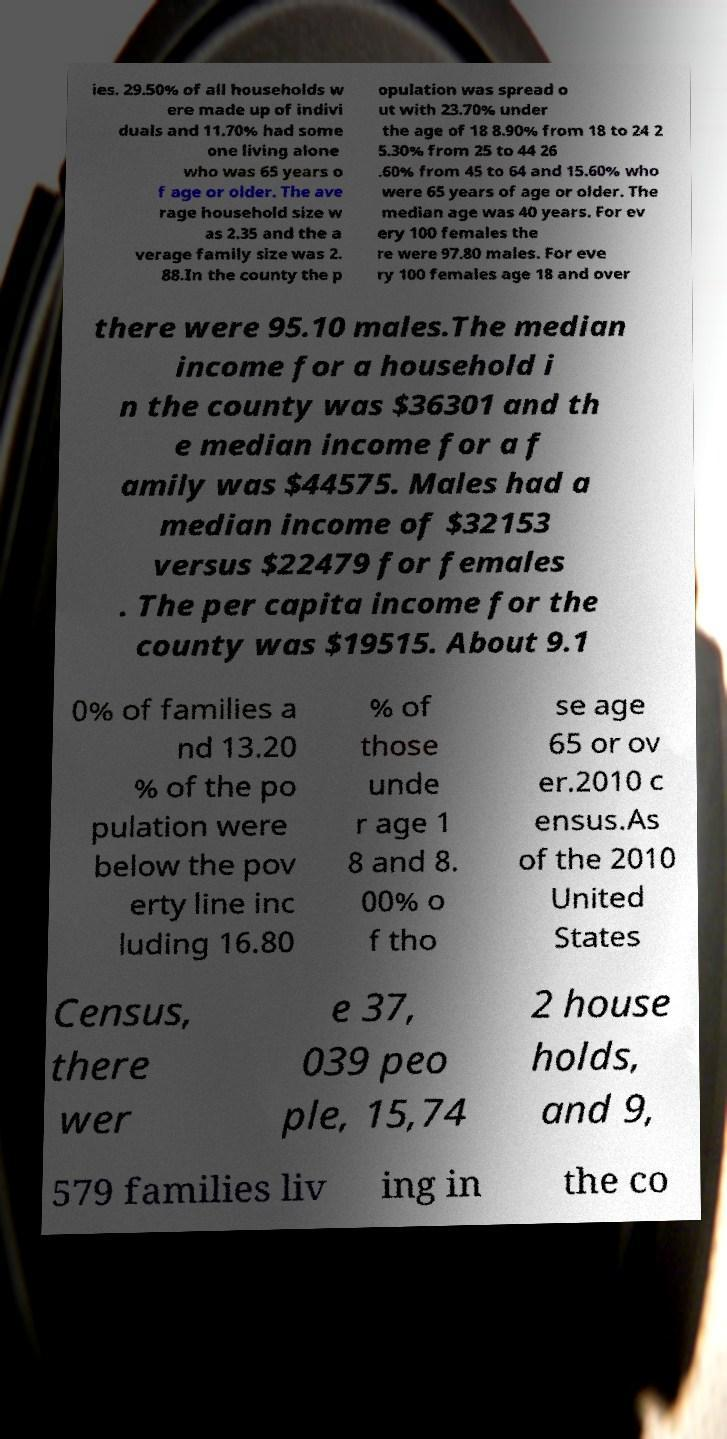Please identify and transcribe the text found in this image. ies. 29.50% of all households w ere made up of indivi duals and 11.70% had some one living alone who was 65 years o f age or older. The ave rage household size w as 2.35 and the a verage family size was 2. 88.In the county the p opulation was spread o ut with 23.70% under the age of 18 8.90% from 18 to 24 2 5.30% from 25 to 44 26 .60% from 45 to 64 and 15.60% who were 65 years of age or older. The median age was 40 years. For ev ery 100 females the re were 97.80 males. For eve ry 100 females age 18 and over there were 95.10 males.The median income for a household i n the county was $36301 and th e median income for a f amily was $44575. Males had a median income of $32153 versus $22479 for females . The per capita income for the county was $19515. About 9.1 0% of families a nd 13.20 % of the po pulation were below the pov erty line inc luding 16.80 % of those unde r age 1 8 and 8. 00% o f tho se age 65 or ov er.2010 c ensus.As of the 2010 United States Census, there wer e 37, 039 peo ple, 15,74 2 house holds, and 9, 579 families liv ing in the co 